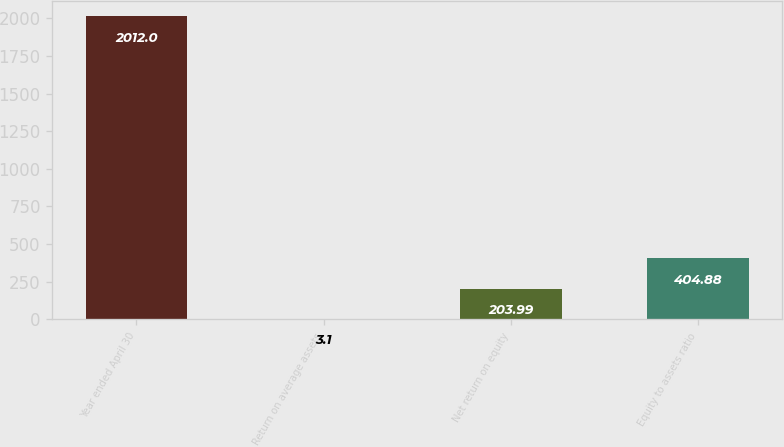Convert chart to OTSL. <chart><loc_0><loc_0><loc_500><loc_500><bar_chart><fcel>Year ended April 30<fcel>Return on average assets<fcel>Net return on equity<fcel>Equity to assets ratio<nl><fcel>2012<fcel>3.1<fcel>203.99<fcel>404.88<nl></chart> 